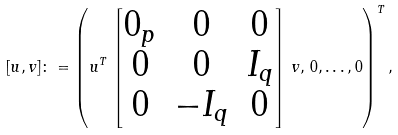Convert formula to latex. <formula><loc_0><loc_0><loc_500><loc_500>[ u , v ] \colon = \left ( u ^ { T } \, \begin{bmatrix} 0 _ { p } & 0 & 0 \\ 0 & 0 & I _ { q } \\ 0 & - I _ { q } & 0 \end{bmatrix} \, v , \, 0 , \dots , 0 \right ) ^ { T } ,</formula> 